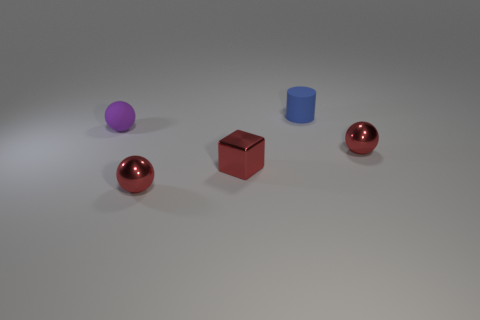What number of other things are the same material as the tiny blue cylinder?
Offer a very short reply. 1. Are there more matte spheres that are right of the purple sphere than red metal balls that are behind the tiny red metallic cube?
Your response must be concise. No. What is the material of the tiny red thing on the right side of the tiny rubber cylinder?
Give a very brief answer. Metal. Do the blue object and the tiny purple matte object have the same shape?
Provide a succinct answer. No. Is there any other thing that is the same color as the tiny shiny cube?
Give a very brief answer. Yes. Are there more small red spheres behind the blue cylinder than small matte cylinders?
Keep it short and to the point. No. The small matte object that is right of the red shiny cube is what color?
Your answer should be very brief. Blue. Is the size of the rubber cylinder the same as the purple matte object?
Your response must be concise. Yes. The cube is what size?
Ensure brevity in your answer.  Small. Is the number of large gray metallic cubes greater than the number of small purple balls?
Your answer should be very brief. No. 